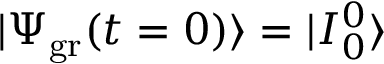<formula> <loc_0><loc_0><loc_500><loc_500>| \Psi _ { g r } ( t = 0 ) \rangle = | I _ { 0 } ^ { 0 } \rangle</formula> 